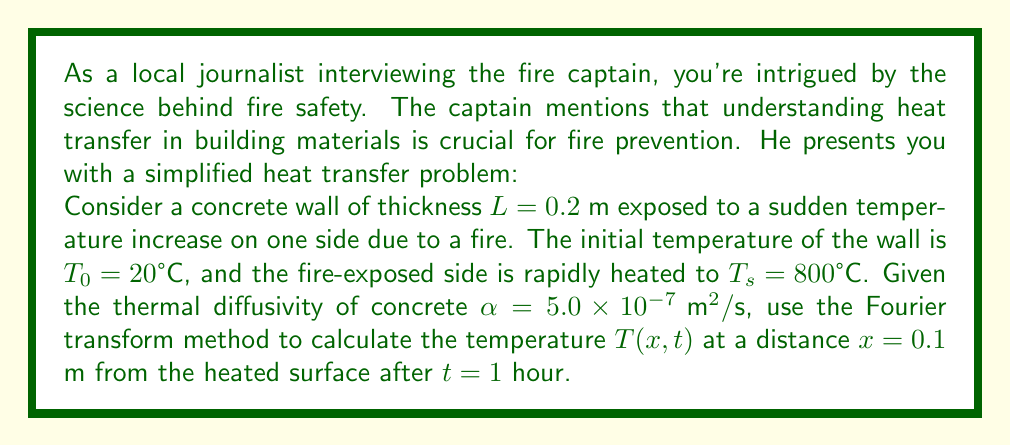Help me with this question. To solve this problem, we'll use the Fourier transform method for the heat equation. Let's break it down step-by-step:

1) The heat equation for this problem is:

   $$\frac{\partial T}{\partial t} = \alpha \frac{\partial^2 T}{\partial x^2}$$

2) The initial and boundary conditions are:
   
   $T(x,0) = T_0 = 20°C$ for $0 < x < L$
   $T(0,t) = T_s = 800°C$ for $t > 0$
   $\frac{\partial T}{\partial x}(L,t) = 0$ for $t > 0$ (insulated end)

3) Let's define $\theta(x,t) = T(x,t) - T_s$. This transforms our problem to:

   $$\frac{\partial \theta}{\partial t} = \alpha \frac{\partial^2 \theta}{\partial x^2}$$

   With conditions:
   $\theta(x,0) = T_0 - T_s = -780°C$
   $\theta(0,t) = 0$
   $\frac{\partial \theta}{\partial x}(L,t) = 0$

4) The solution using Fourier series is:

   $$\theta(x,t) = \sum_{n=0}^{\infty} B_n \cos(\beta_n x) e^{-\alpha \beta_n^2 t}$$

   Where $\beta_n = \frac{(2n+1)\pi}{2L}$

5) The coefficients $B_n$ are given by:

   $$B_n = \frac{2}{L} \int_0^L (T_0 - T_s) \cos(\beta_n x) dx = \frac{4(T_0 - T_s)}{(2n+1)\pi} (-1)^n$$

6) Substituting the values:

   $$\theta(x,t) = -780 \sum_{n=0}^{\infty} \frac{4}{(2n+1)\pi} (-1)^n \cos(\frac{(2n+1)\pi x}{0.4}) e^{-5.0 \times 10^{-7} (\frac{(2n+1)\pi}{0.4})^2 3600}$$

7) For $x = 0.1$ m and $t = 1$ hour = 3600 s:

   $$\theta(0.1, 3600) \approx -193.8°C$$

8) Therefore, $T(0.1, 3600) = \theta(0.1, 3600) + T_s \approx -193.8 + 800 = 606.2°C$
Answer: $T(0.1, 3600) \approx 606.2°C$ 